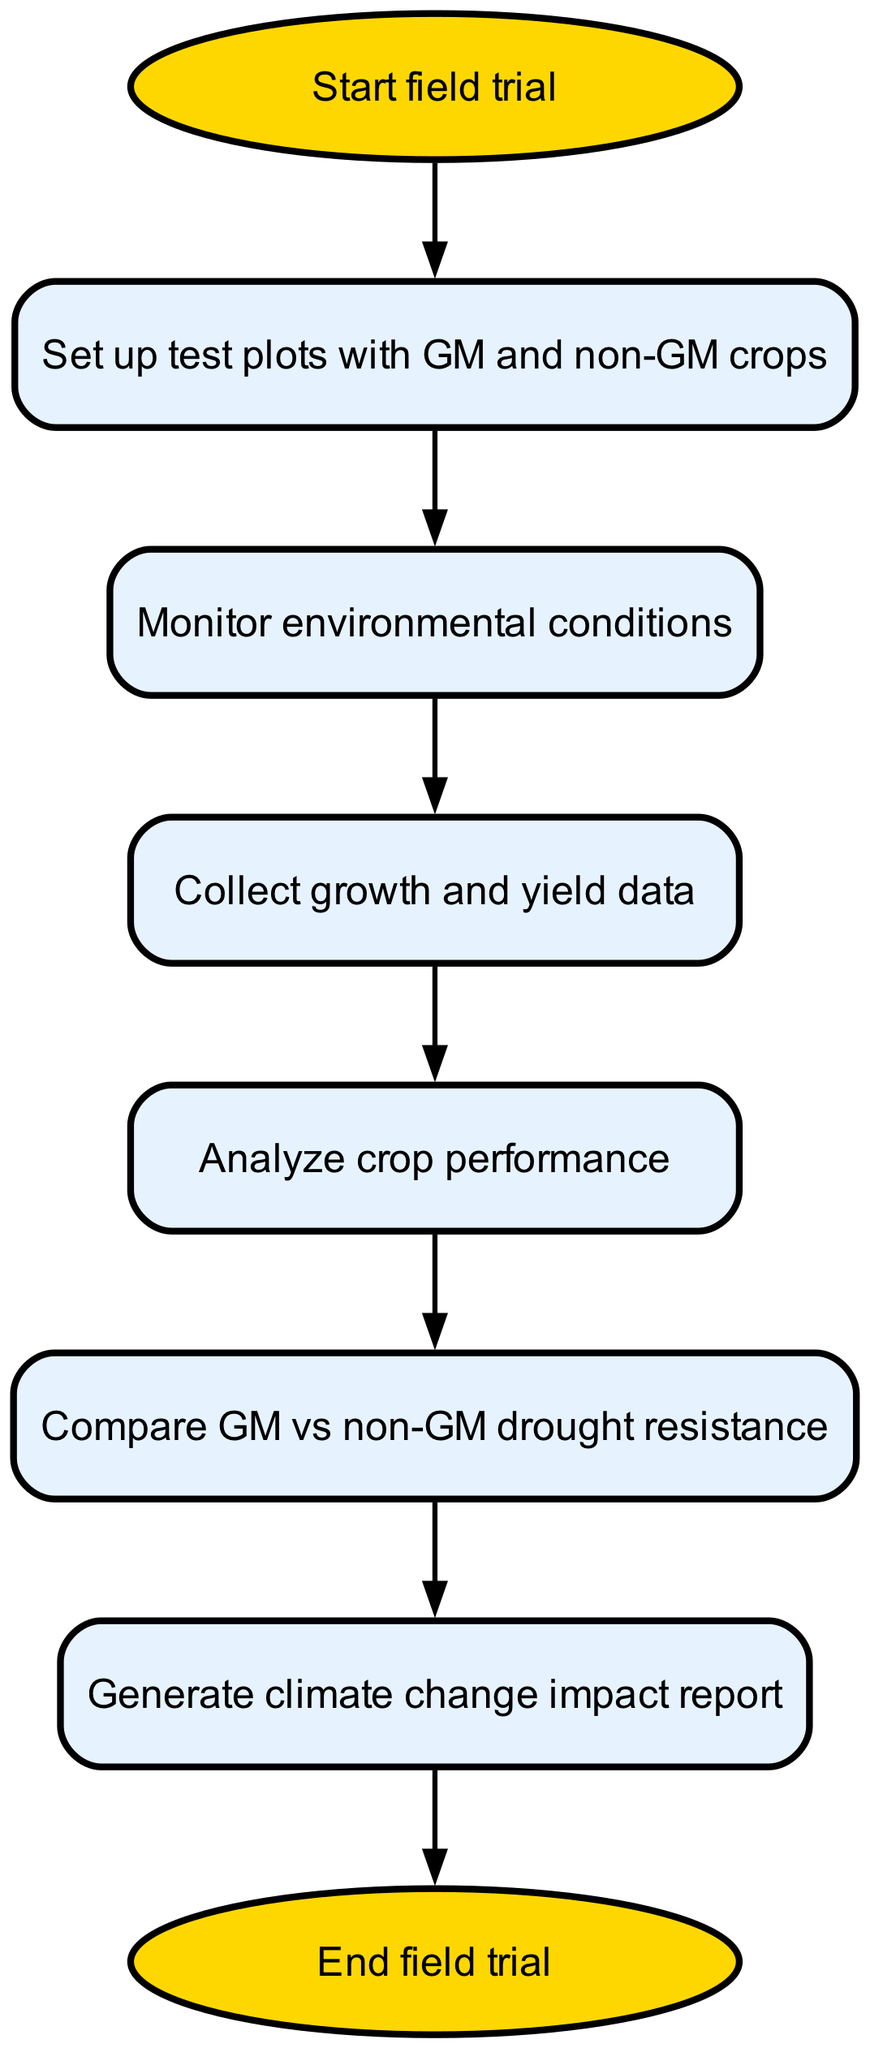What is the first step in the field trial process? The first step in the flowchart is indicated by the "Start field trial" node, which directly leads to the next step.
Answer: Start field trial How many nodes are present in the diagram? By counting all the nodes, including the start and end nodes, there are a total of eight nodes in the diagram.
Answer: Eight What is the last step before generating the report? The last step before reaching the "Generate climate change impact report" node is "Compare GM vs non-GM drought resistance," which directly precedes the report generation.
Answer: Compare GM vs non-GM drought resistance Name the process that follows data collection. After the "Collect growth and yield data" node in the flowchart, the subsequent process is "Analyze crop performance."
Answer: Analyze crop performance What type of crops are used in the field trial? The field trial involves test plots with genetically modified (GM) and non-GM crops as specified in the "Set up test plots with GM and non-GM crops" node.
Answer: GM and non-GM crops What leads to the end of the trial? The flow leads to the "End field trial" node after the completion of the "Generate climate change impact report." The report generation is the last action that precedes the trial's conclusion.
Answer: Generate climate change impact report Which step involves environmental monitoring? The "Monitor environmental conditions" node is dedicated to the task of tracking the environmental factors affecting crop performance, making it focused on monitoring.
Answer: Monitor environmental conditions What action directly follows analyzing crop performance? After the "Analyze crop performance," the next action in the flowchart is "Compare GM vs non-GM drought resistance." This establishes a sequence for assessing the results.
Answer: Compare GM vs non-GM drought resistance 